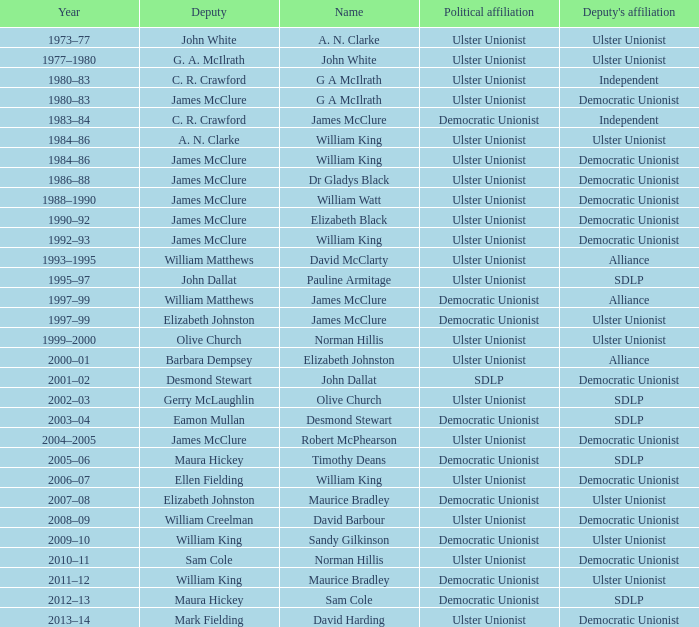What was the deputy called when the name in question was elizabeth black? James McClure. 